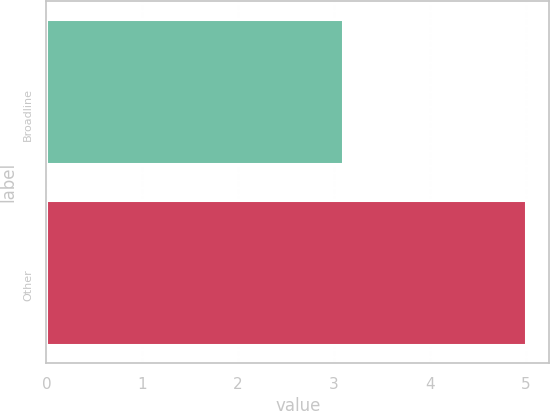Convert chart. <chart><loc_0><loc_0><loc_500><loc_500><bar_chart><fcel>Broadline<fcel>Other<nl><fcel>3.1<fcel>5<nl></chart> 